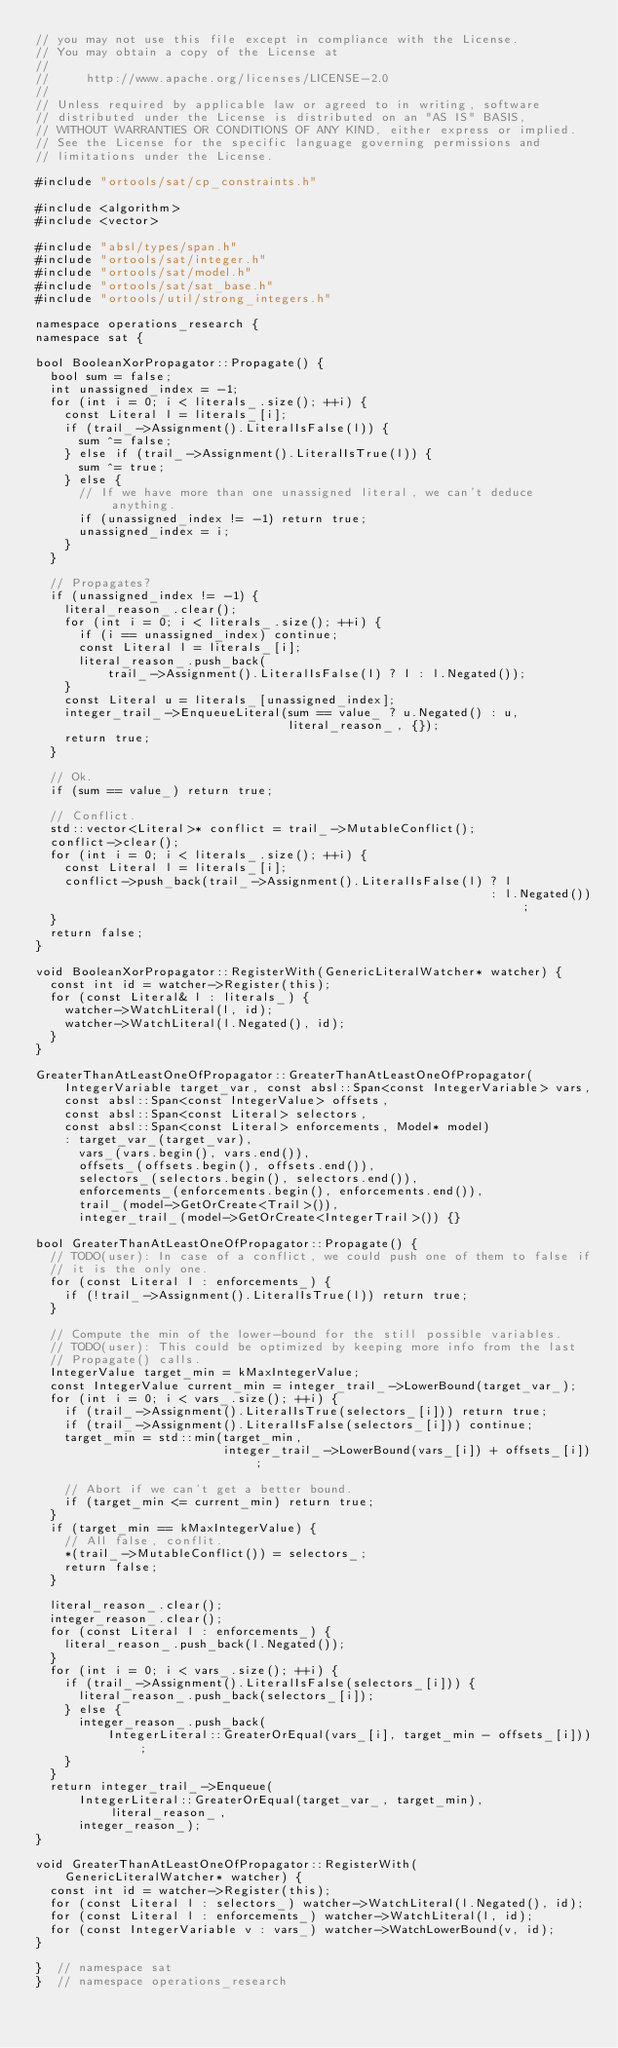<code> <loc_0><loc_0><loc_500><loc_500><_C++_>// you may not use this file except in compliance with the License.
// You may obtain a copy of the License at
//
//     http://www.apache.org/licenses/LICENSE-2.0
//
// Unless required by applicable law or agreed to in writing, software
// distributed under the License is distributed on an "AS IS" BASIS,
// WITHOUT WARRANTIES OR CONDITIONS OF ANY KIND, either express or implied.
// See the License for the specific language governing permissions and
// limitations under the License.

#include "ortools/sat/cp_constraints.h"

#include <algorithm>
#include <vector>

#include "absl/types/span.h"
#include "ortools/sat/integer.h"
#include "ortools/sat/model.h"
#include "ortools/sat/sat_base.h"
#include "ortools/util/strong_integers.h"

namespace operations_research {
namespace sat {

bool BooleanXorPropagator::Propagate() {
  bool sum = false;
  int unassigned_index = -1;
  for (int i = 0; i < literals_.size(); ++i) {
    const Literal l = literals_[i];
    if (trail_->Assignment().LiteralIsFalse(l)) {
      sum ^= false;
    } else if (trail_->Assignment().LiteralIsTrue(l)) {
      sum ^= true;
    } else {
      // If we have more than one unassigned literal, we can't deduce anything.
      if (unassigned_index != -1) return true;
      unassigned_index = i;
    }
  }

  // Propagates?
  if (unassigned_index != -1) {
    literal_reason_.clear();
    for (int i = 0; i < literals_.size(); ++i) {
      if (i == unassigned_index) continue;
      const Literal l = literals_[i];
      literal_reason_.push_back(
          trail_->Assignment().LiteralIsFalse(l) ? l : l.Negated());
    }
    const Literal u = literals_[unassigned_index];
    integer_trail_->EnqueueLiteral(sum == value_ ? u.Negated() : u,
                                   literal_reason_, {});
    return true;
  }

  // Ok.
  if (sum == value_) return true;

  // Conflict.
  std::vector<Literal>* conflict = trail_->MutableConflict();
  conflict->clear();
  for (int i = 0; i < literals_.size(); ++i) {
    const Literal l = literals_[i];
    conflict->push_back(trail_->Assignment().LiteralIsFalse(l) ? l
                                                               : l.Negated());
  }
  return false;
}

void BooleanXorPropagator::RegisterWith(GenericLiteralWatcher* watcher) {
  const int id = watcher->Register(this);
  for (const Literal& l : literals_) {
    watcher->WatchLiteral(l, id);
    watcher->WatchLiteral(l.Negated(), id);
  }
}

GreaterThanAtLeastOneOfPropagator::GreaterThanAtLeastOneOfPropagator(
    IntegerVariable target_var, const absl::Span<const IntegerVariable> vars,
    const absl::Span<const IntegerValue> offsets,
    const absl::Span<const Literal> selectors,
    const absl::Span<const Literal> enforcements, Model* model)
    : target_var_(target_var),
      vars_(vars.begin(), vars.end()),
      offsets_(offsets.begin(), offsets.end()),
      selectors_(selectors.begin(), selectors.end()),
      enforcements_(enforcements.begin(), enforcements.end()),
      trail_(model->GetOrCreate<Trail>()),
      integer_trail_(model->GetOrCreate<IntegerTrail>()) {}

bool GreaterThanAtLeastOneOfPropagator::Propagate() {
  // TODO(user): In case of a conflict, we could push one of them to false if
  // it is the only one.
  for (const Literal l : enforcements_) {
    if (!trail_->Assignment().LiteralIsTrue(l)) return true;
  }

  // Compute the min of the lower-bound for the still possible variables.
  // TODO(user): This could be optimized by keeping more info from the last
  // Propagate() calls.
  IntegerValue target_min = kMaxIntegerValue;
  const IntegerValue current_min = integer_trail_->LowerBound(target_var_);
  for (int i = 0; i < vars_.size(); ++i) {
    if (trail_->Assignment().LiteralIsTrue(selectors_[i])) return true;
    if (trail_->Assignment().LiteralIsFalse(selectors_[i])) continue;
    target_min = std::min(target_min,
                          integer_trail_->LowerBound(vars_[i]) + offsets_[i]);

    // Abort if we can't get a better bound.
    if (target_min <= current_min) return true;
  }
  if (target_min == kMaxIntegerValue) {
    // All false, conflit.
    *(trail_->MutableConflict()) = selectors_;
    return false;
  }

  literal_reason_.clear();
  integer_reason_.clear();
  for (const Literal l : enforcements_) {
    literal_reason_.push_back(l.Negated());
  }
  for (int i = 0; i < vars_.size(); ++i) {
    if (trail_->Assignment().LiteralIsFalse(selectors_[i])) {
      literal_reason_.push_back(selectors_[i]);
    } else {
      integer_reason_.push_back(
          IntegerLiteral::GreaterOrEqual(vars_[i], target_min - offsets_[i]));
    }
  }
  return integer_trail_->Enqueue(
      IntegerLiteral::GreaterOrEqual(target_var_, target_min), literal_reason_,
      integer_reason_);
}

void GreaterThanAtLeastOneOfPropagator::RegisterWith(
    GenericLiteralWatcher* watcher) {
  const int id = watcher->Register(this);
  for (const Literal l : selectors_) watcher->WatchLiteral(l.Negated(), id);
  for (const Literal l : enforcements_) watcher->WatchLiteral(l, id);
  for (const IntegerVariable v : vars_) watcher->WatchLowerBound(v, id);
}

}  // namespace sat
}  // namespace operations_research
</code> 